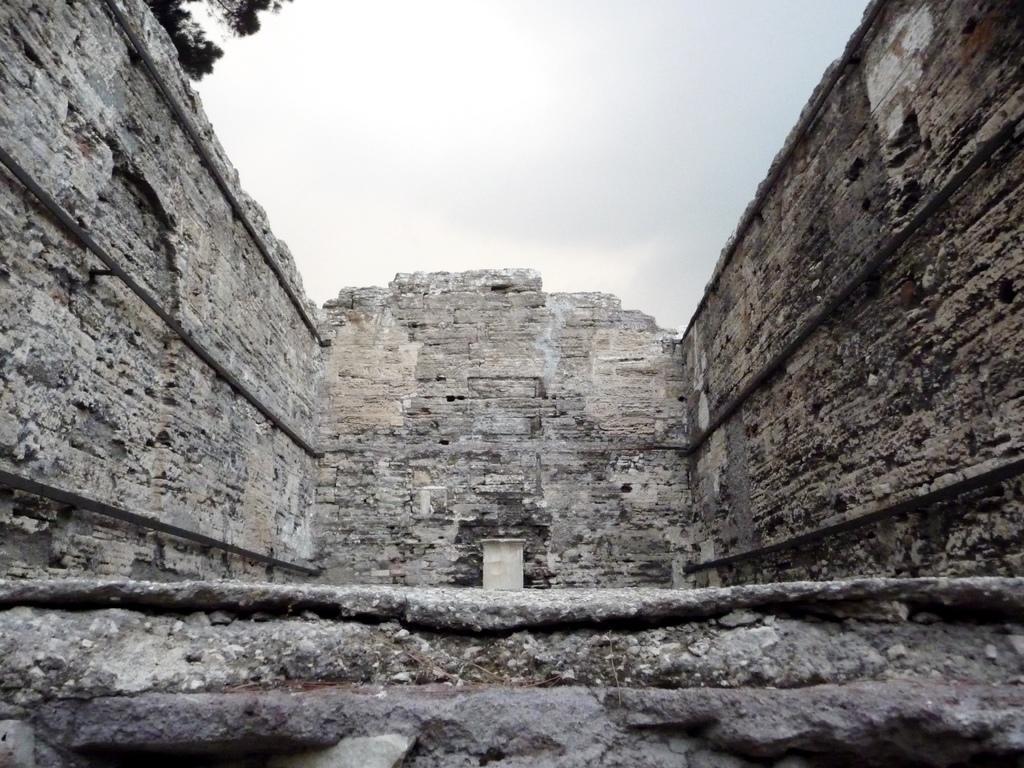Can you describe this image briefly? In this picture we can see the walls of a building and there is sky at the top side of the image, it seems to be there is a tree at the top side of the image. 